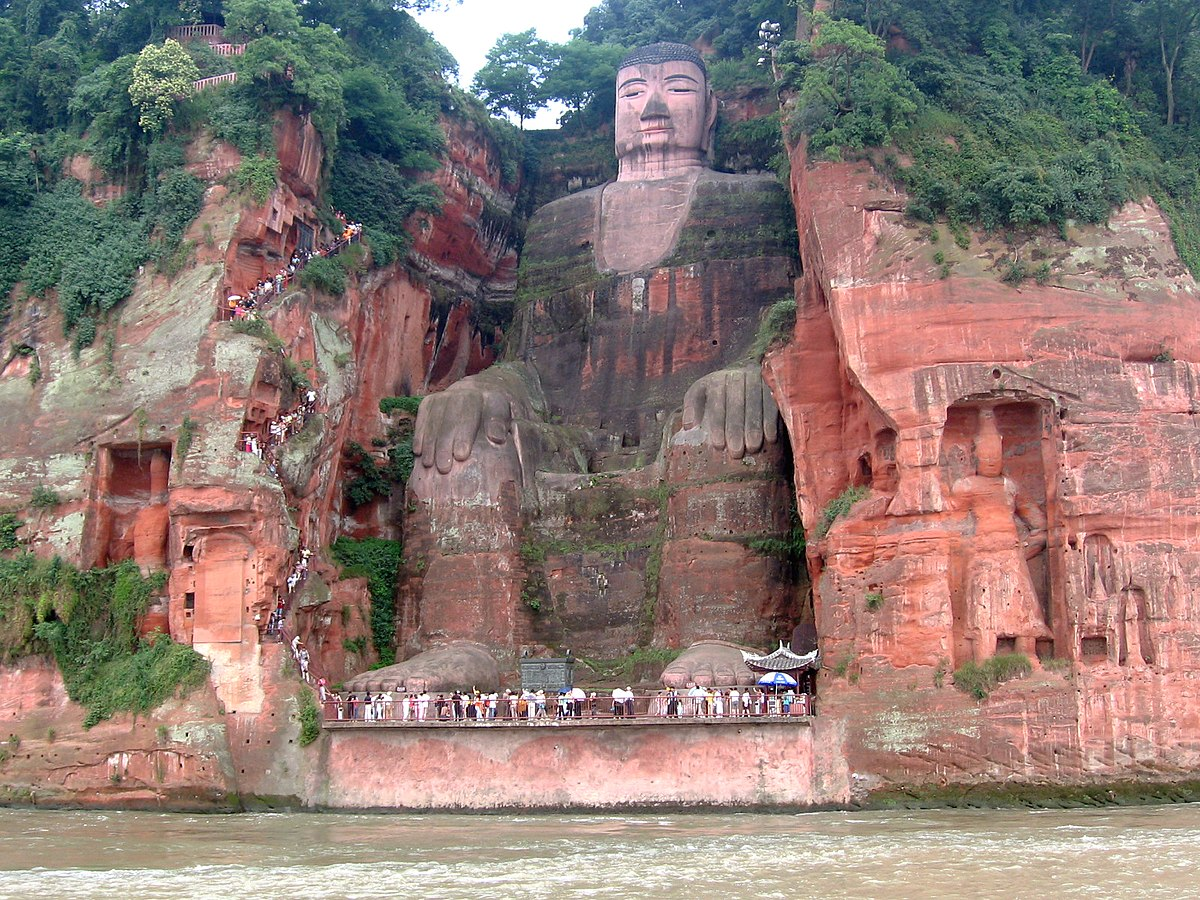What do you think is going on in this snapshot? This image showcases the magnificent Leshan Giant Buddha, a colossal statue carved into a cliff face in Leshan, Sichuan province, China. Standing 71 meters tall, this Buddha is the largest carved stone Buddha in the world and a profound symbol of peace and serenity. Beyond its staggering size, the statue's craftsmanship is an outstanding example of pre-modern engineering and artistic expertise.

Constructed during the Tang Dynasty between 713 and 803 AD to calm the turbulent waters of the confluence of three rivers, it is both a marvel of religious significance and a protective monument. Today, visitors from all around the globe gather to witness its grandeur, marveling at its detailed carvings and the surrounding lush greenery. The serene expression of the Buddha, coupled with the tranquil river below and the vibrant forest canopy, transformers this setting into a place of quiet reflection and awe. 